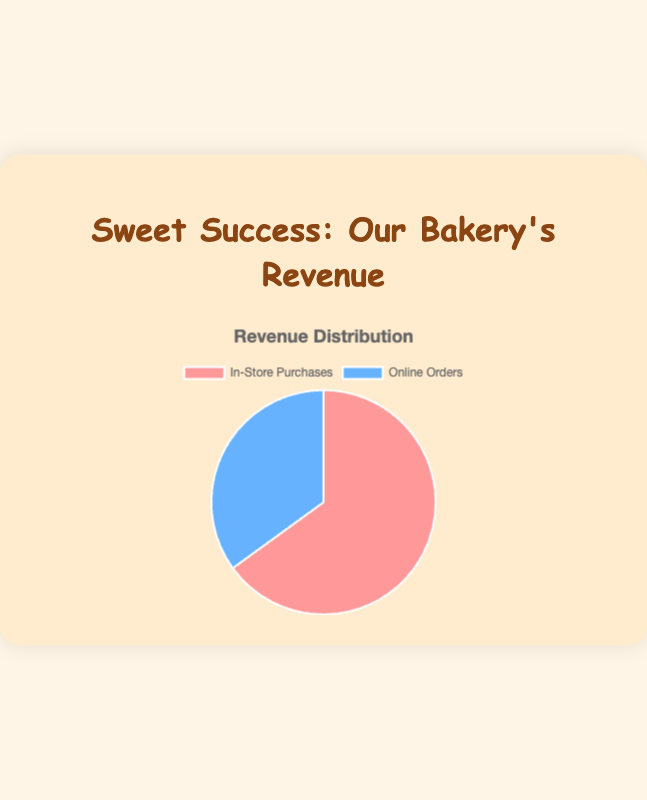What percentage of the total revenue comes from in-store purchases? The total revenue is the sum of in-store purchases and online orders, which is 6500 + 3500 = 10000. The percentage for in-store purchases is (6500 / 10000) * 100 = 65%
Answer: 65% What is the difference in revenue between in-store purchases and online orders? The difference in revenue is calculated by subtracting the revenue from online orders from the revenue from in-store purchases, which is 6500 - 3500 = 3000
Answer: 3000 If the total revenue were distributed equally between in-store purchases and online orders, how much revenue would each category have? If the total revenue of 10000 were distributed equally, each category would have 10000 / 2 = 5000
Answer: 5000 Which category has the highest revenue? The revenue for in-store purchases is 6500, and for online orders, it is 3500. Since 6500 is greater than 3500, in-store purchases have the highest revenue.
Answer: In-store purchases What color represents online orders in the pie chart? In the chart, online orders are represented by the color blue.
Answer: Blue By what factor is the revenue from in-store purchases greater than the revenue from online orders? The factor is determined by dividing the revenue from in-store purchases by the revenue from online orders, which is 6500 / 3500 ≈ 1.86
Answer: 1.86 What is the combined total revenue from both categories? The combined total revenue is the sum of the revenue from in-store purchases and online orders, which is 6500 + 3500 = 10000
Answer: 10000 Out of every £100 earned, how much comes from online orders? To find out how much comes from online orders out of every £100 earned, we use the percentage of total revenue from online orders, which is 35%. This means £35 out of every £100 earned comes from online orders.
Answer: £35 